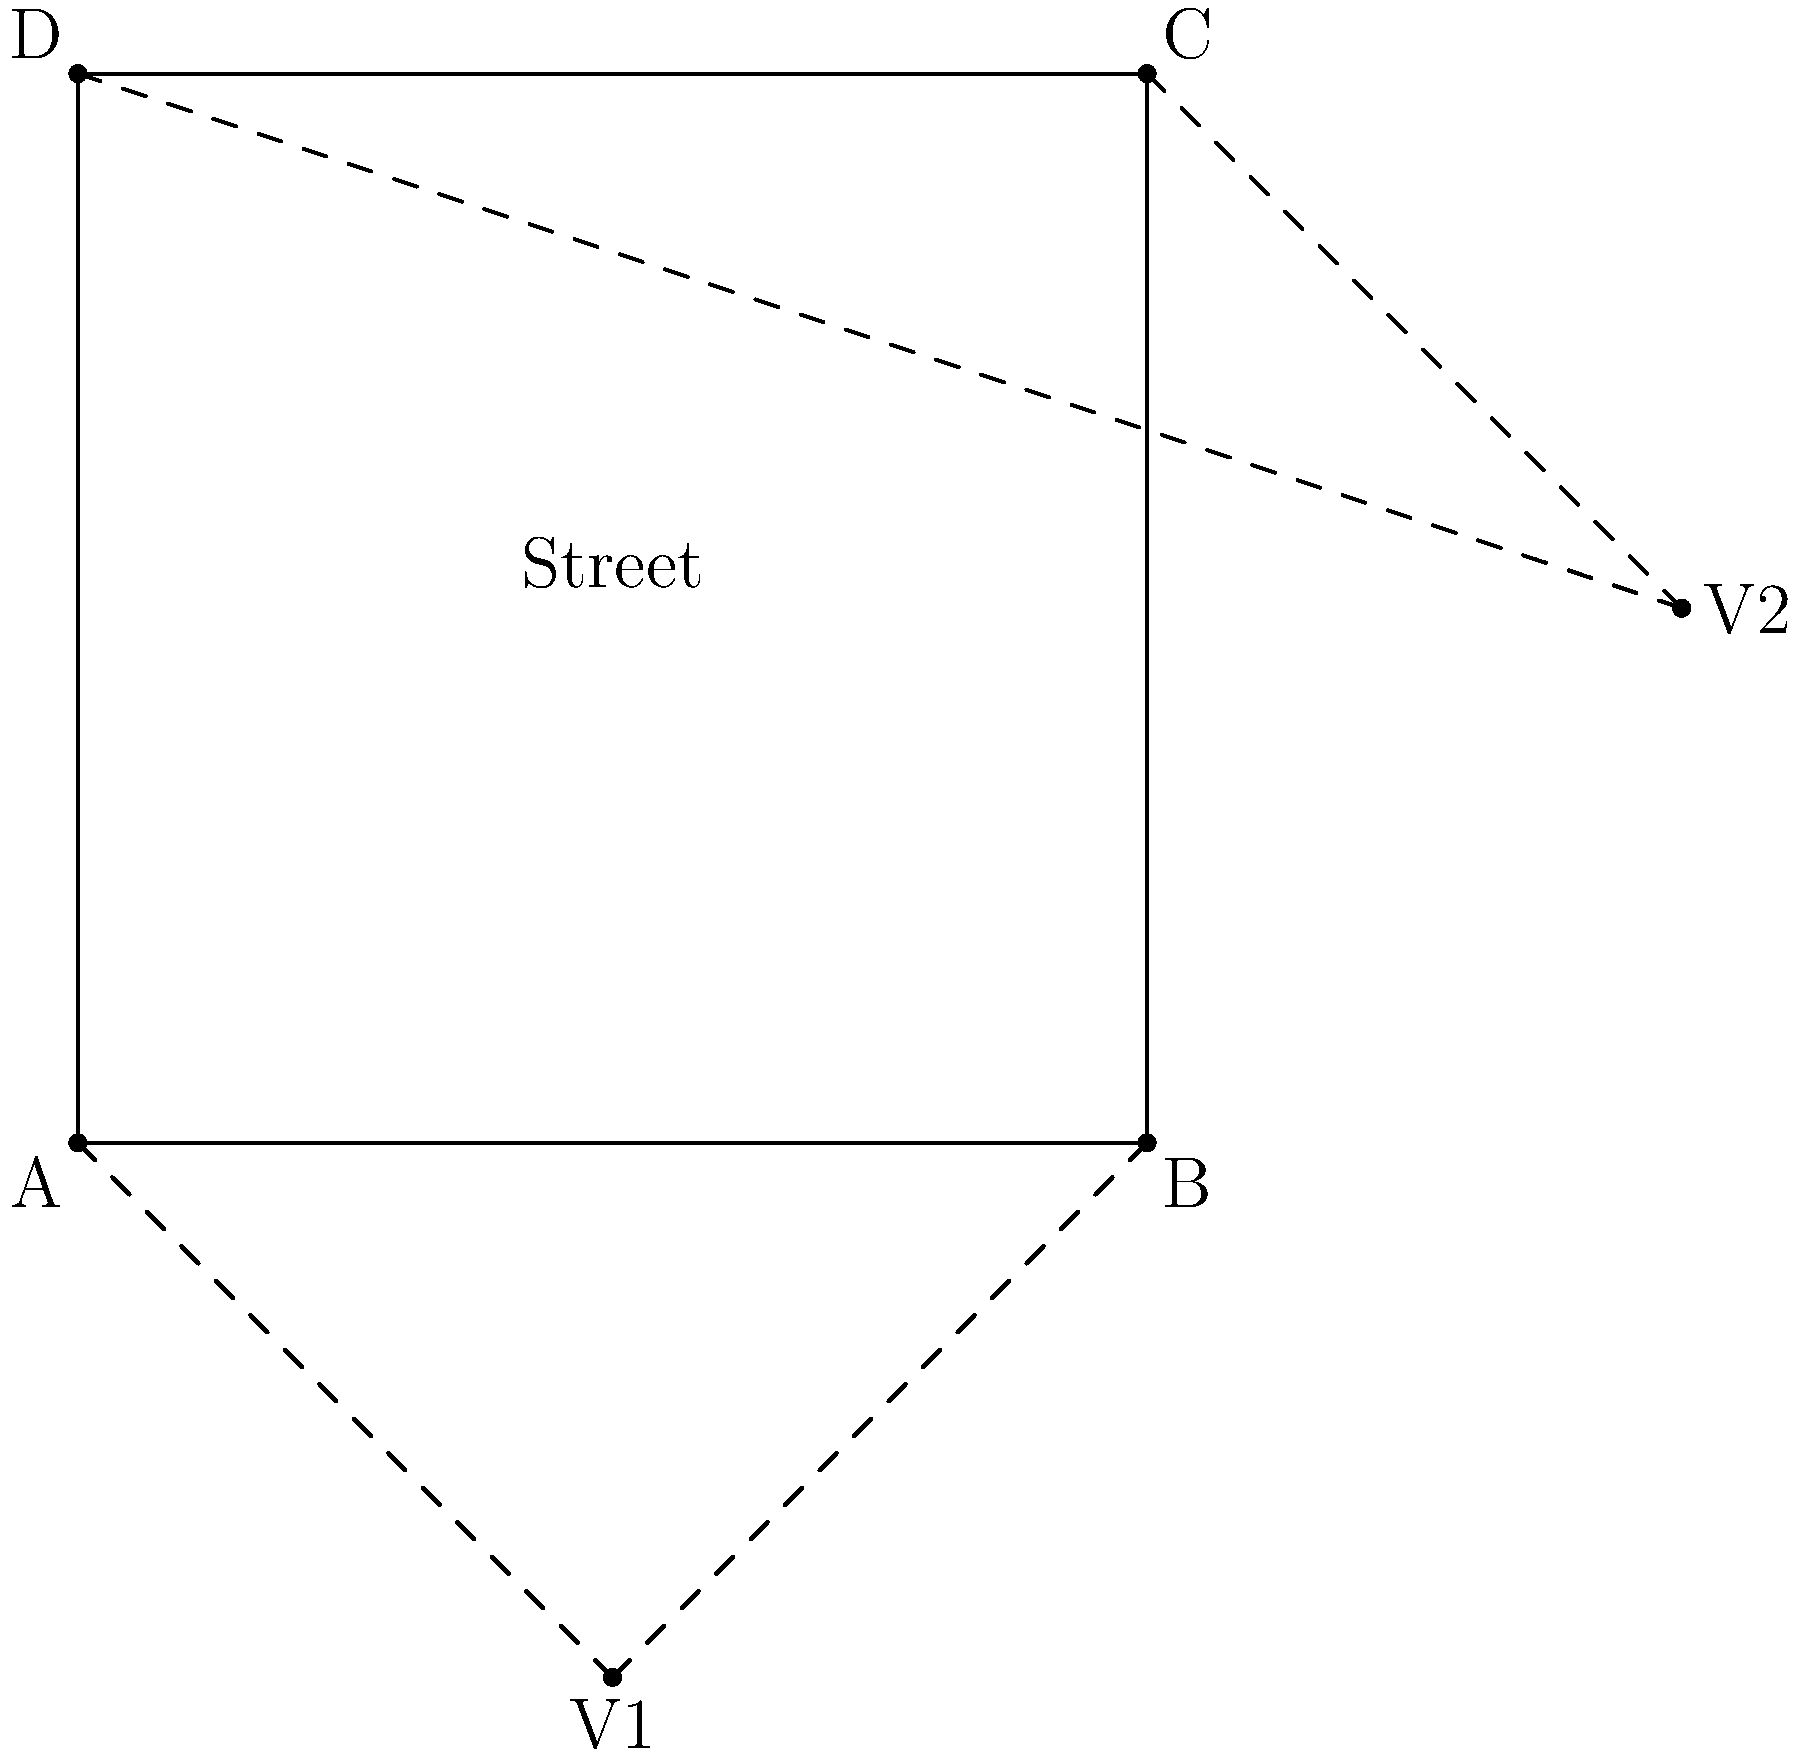For your street art installation, you're planning a mural on a rectangular wall with dimensions 10m x 8m. You've sketched a perspective drawing with two vanishing points, V1 and V2, as shown in the diagram. If the distance between V1 and V2 is 20m, and V1 is located 5m below the bottom edge of the wall, calculate the distance from the bottom-left corner of the wall (point A) to V1. Let's approach this step-by-step:

1) First, let's define our coordinate system. Let's place point A at (0,0), with the wall extending 10m to the right and 8m up.

2) We know that V1 is 5m below the bottom edge of the wall, so its y-coordinate is -5m.

3) Let's call the x-coordinate of V1 as x. We need to find x.

4) We know that the distance between V1 and V2 is 20m. We can use this information to set up an equation.

5) The coordinates of V2 are (x+10, 3), because it's 10m to the right of V1 (the width of the wall) and 8m above V1 (5m below the wall + 8m height of the wall).

6) We can use the distance formula between two points:
   $$(x+10-x)^2 + (3-(-5))^2 = 20^2$$

7) Simplifying:
   $$10^2 + 8^2 = 20^2$$
   $$100 + 64 = 400$$
   $$164 = 400$$

8) This equation is true, which confirms our setup is correct.

9) Now, to find the distance from A to V1, we can use the distance formula again:
   $$d = \sqrt{x^2 + (-5)^2}$$

10) We don't know x, but we can find it. Since V1 is directly below the midpoint of AB, x = 5m.

11) Plugging this in:
    $$d = \sqrt{5^2 + (-5)^2} = \sqrt{25 + 25} = \sqrt{50} = 5\sqrt{2} \approx 7.07$$m
Answer: $5\sqrt{2}$ m or approximately 7.07m 